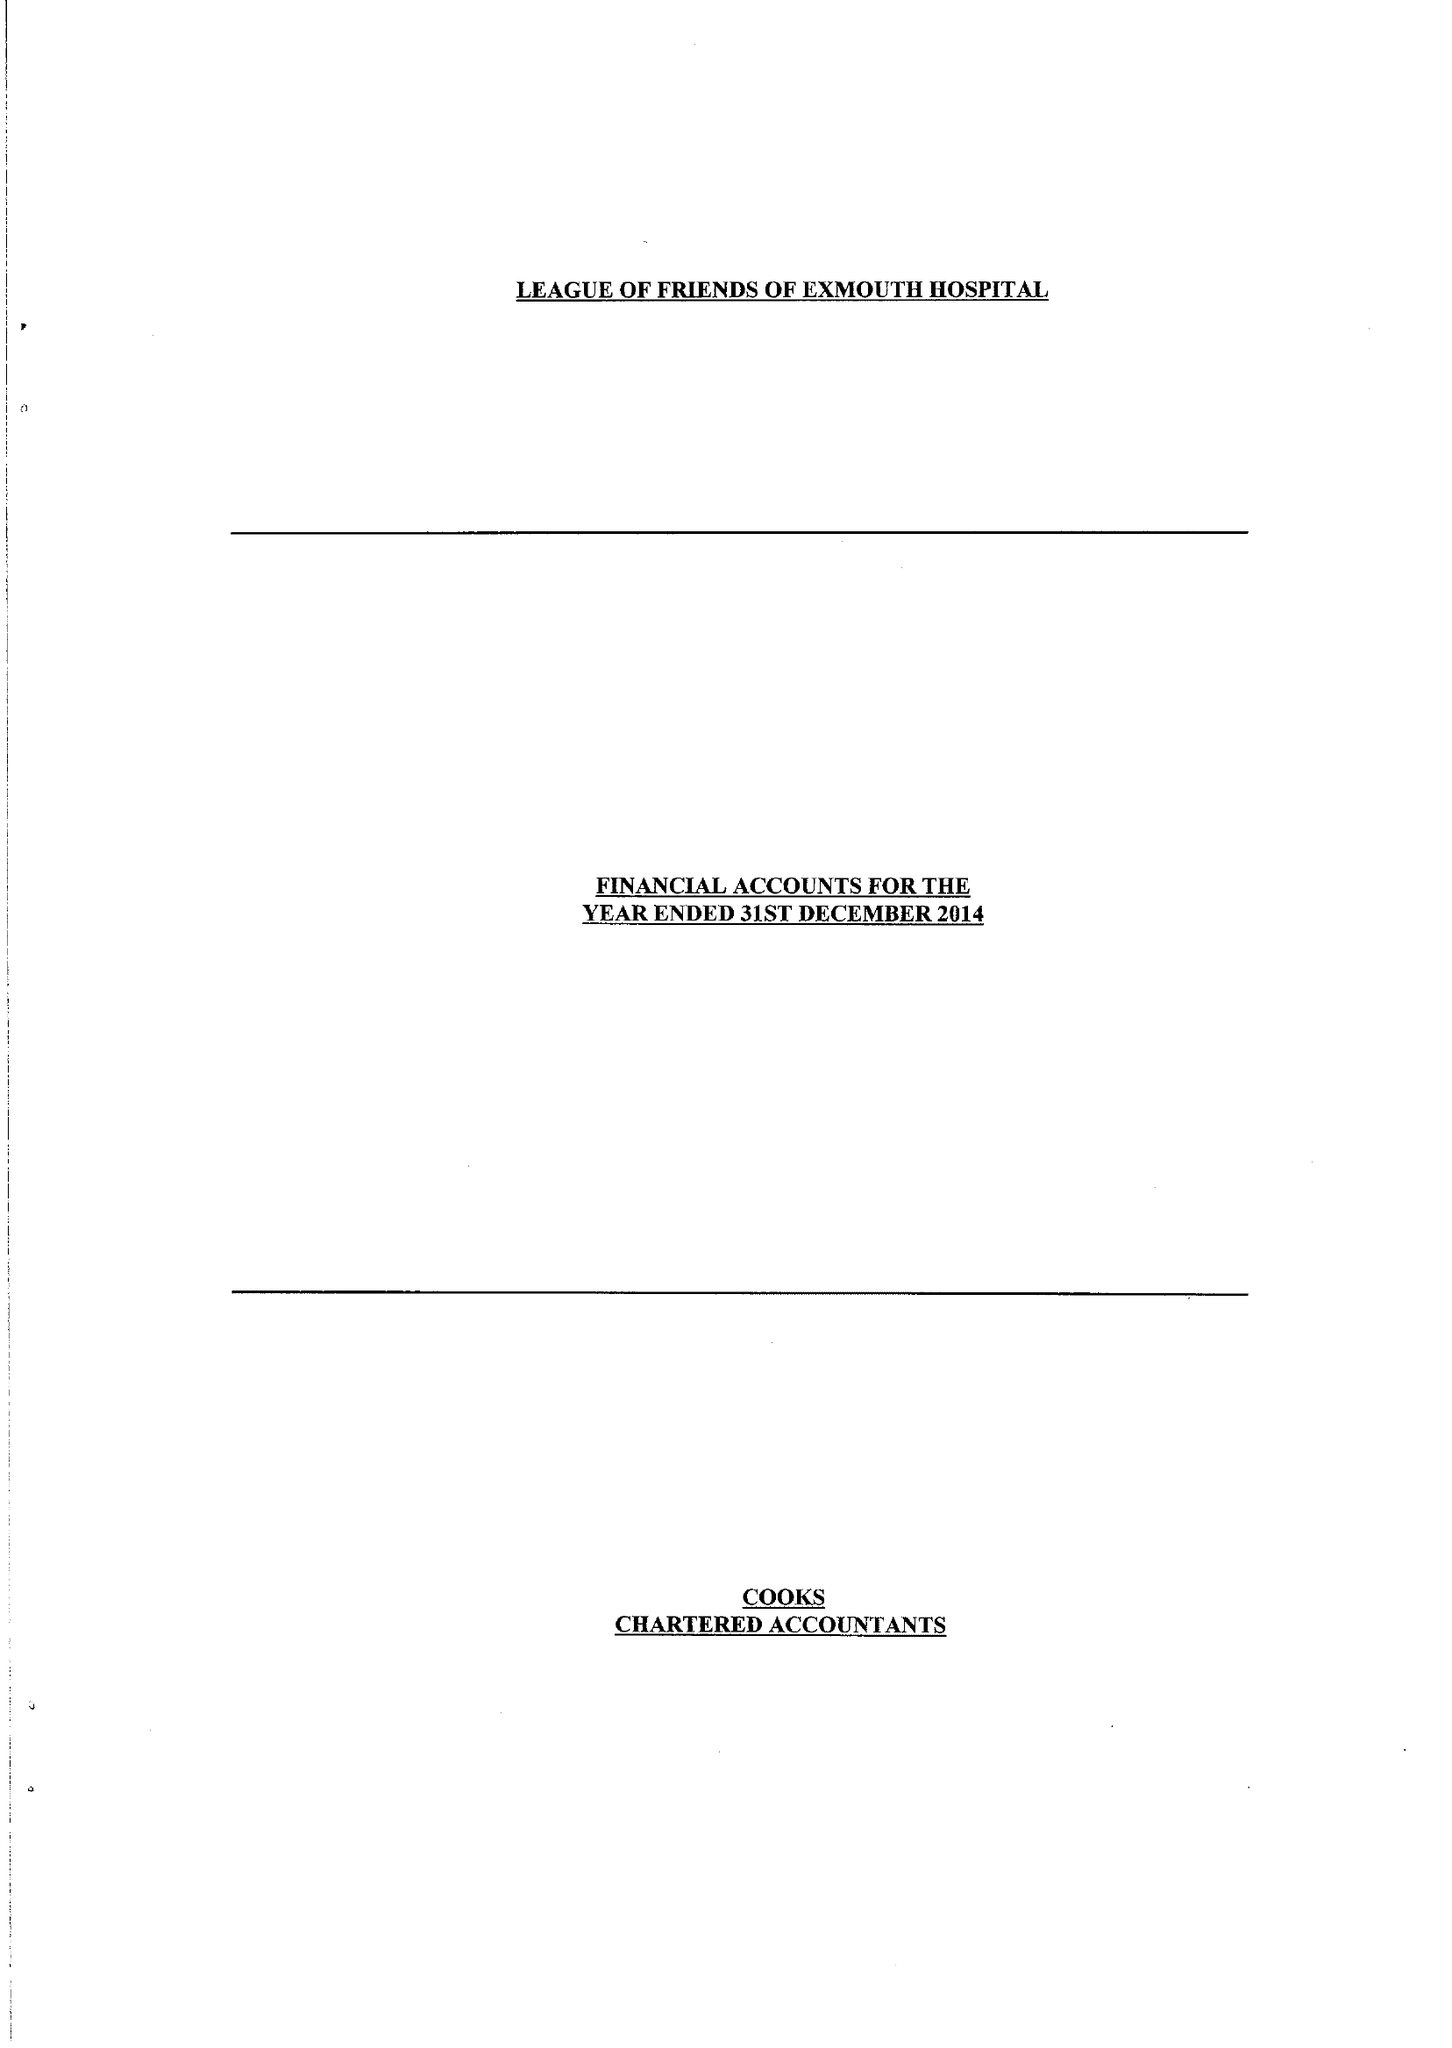What is the value for the charity_number?
Answer the question using a single word or phrase. 254353 